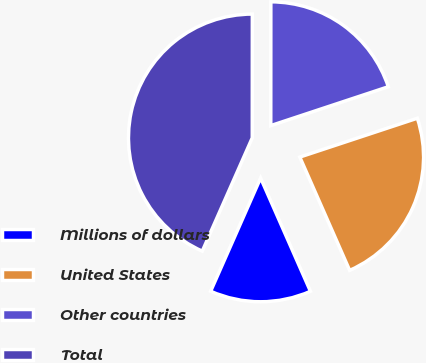Convert chart. <chart><loc_0><loc_0><loc_500><loc_500><pie_chart><fcel>Millions of dollars<fcel>United States<fcel>Other countries<fcel>Total<nl><fcel>13.21%<fcel>23.49%<fcel>19.91%<fcel>43.4%<nl></chart> 